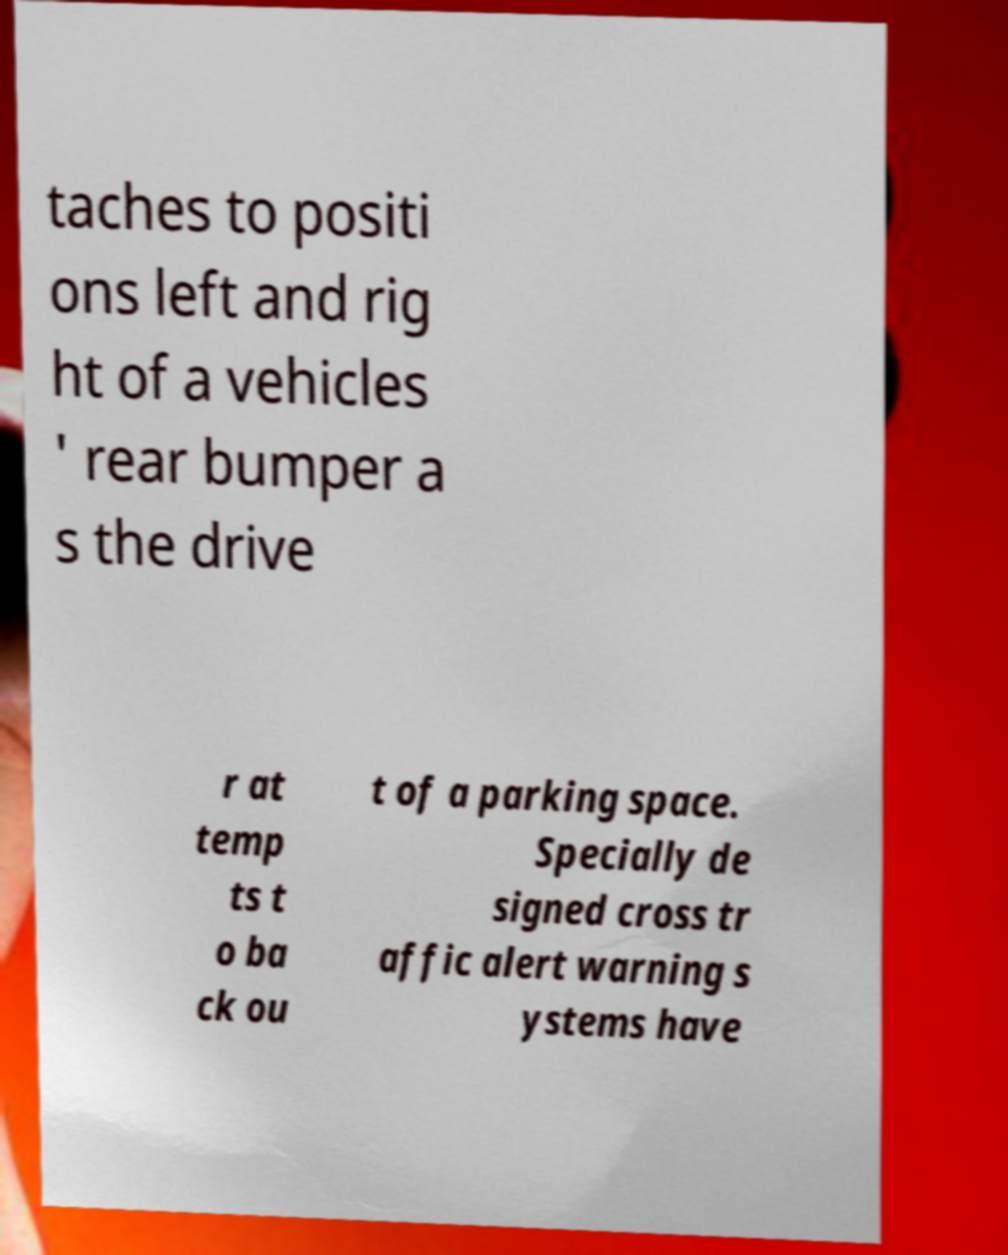Can you accurately transcribe the text from the provided image for me? taches to positi ons left and rig ht of a vehicles ' rear bumper a s the drive r at temp ts t o ba ck ou t of a parking space. Specially de signed cross tr affic alert warning s ystems have 